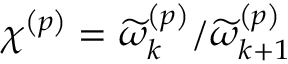Convert formula to latex. <formula><loc_0><loc_0><loc_500><loc_500>\chi ^ { \left ( p \right ) } = \widetilde { \omega } _ { k } ^ { \left ( p \right ) } / \widetilde { \omega } _ { k + 1 } ^ { \left ( p \right ) }</formula> 